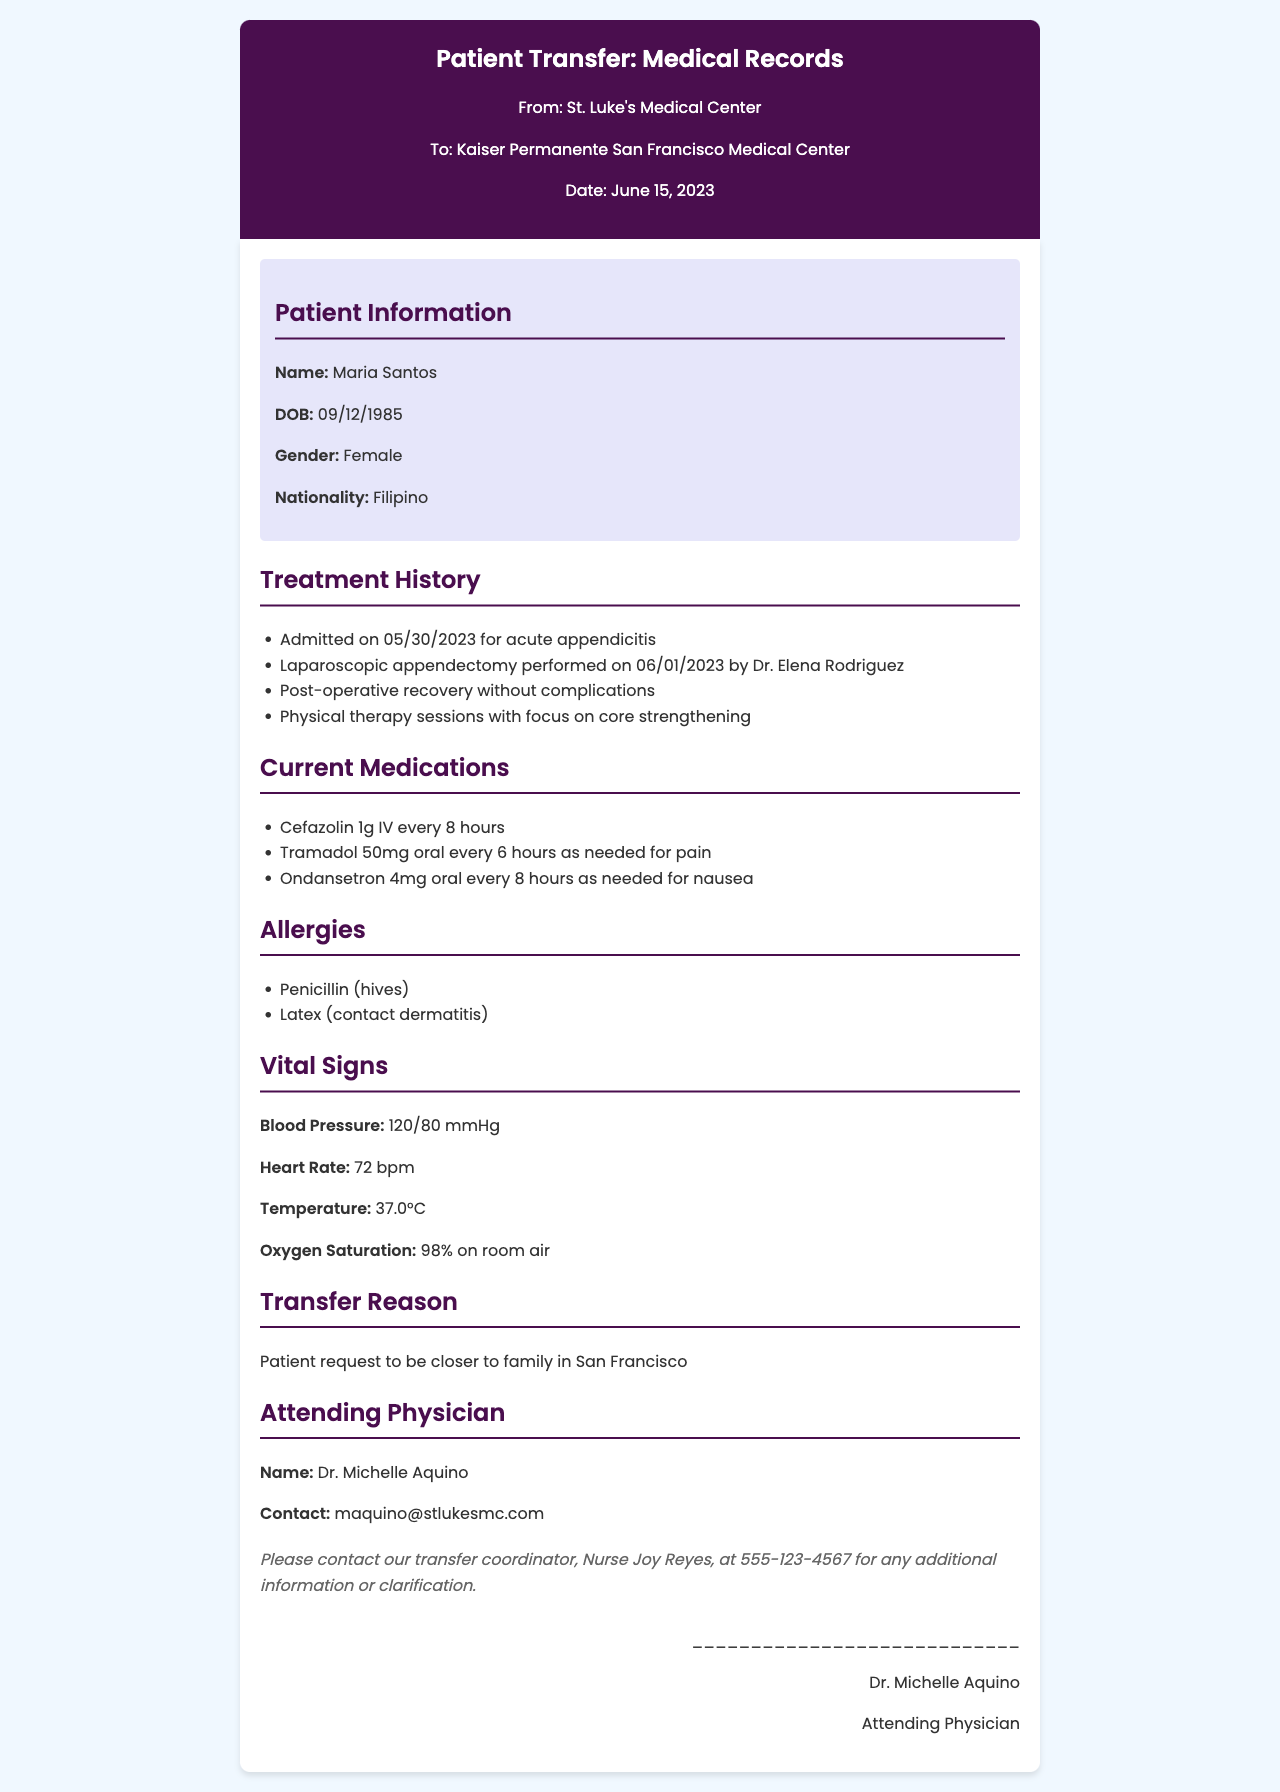What is the patient's name? The patient's name is stated in the patient information section of the document.
Answer: Maria Santos What is the date of admission? The admission date is indicated in the treatment history section of the document.
Answer: 05/30/2023 Who performed the appendectomy? The surgeon's name is mentioned in the treatment history section as the person who conducted the surgery.
Answer: Dr. Elena Rodriguez What medication is given for nausea? The current medications section specifies which medication is prescribed for nausea.
Answer: Ondansetron 4mg oral every 8 hours as needed for nausea What is the patient's reason for transfer? The reason for transfer is included in the document, specifically mentioned in the transfer reason section.
Answer: Patient request to be closer to family in San Francisco What is the attending physician's contact email? The contact information for the attending physician is provided in the attending physician section of the document.
Answer: maquino@stlukesmc.com How many hours apart is the Cefazolin administered? The current medication list specifies the administration frequency of Cefazolin.
Answer: every 8 hours What was the patient's vital sign for blood pressure? The vital signs section includes the patient's blood pressure measurement.
Answer: 120/80 mmHg What is the patient's nationality? The patient's nationality is listed in the patient information section.
Answer: Filipino 